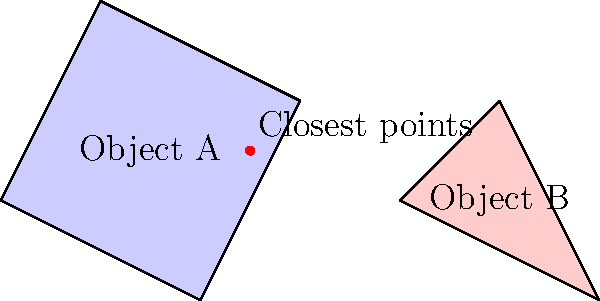In a physics-based puzzle game, you need to calculate the collision detection between two irregularly shaped objects, A and B, as shown in the diagram. If the shortest distance between any two points on these objects is less than 0.5 units, a collision occurs. Given that the closest points between the objects are (2.5, 0.5) on object A and (4, 0) on object B, determine if a collision has occurred. What is the distance between these closest points? To solve this problem, we need to calculate the distance between the two closest points and compare it to the collision threshold. Let's break it down step-by-step:

1. Identify the coordinates of the closest points:
   - Point on Object A: (2.5, 0.5)
   - Point on Object B: (4, 0)

2. Calculate the distance using the distance formula between two points:
   $d = \sqrt{(x_2 - x_1)^2 + (y_2 - y_1)^2}$

   Where:
   $(x_1, y_1)$ is (2.5, 0.5)
   $(x_2, y_2)$ is (4, 0)

3. Plug the values into the formula:
   $d = \sqrt{(4 - 2.5)^2 + (0 - 0.5)^2}$

4. Simplify:
   $d = \sqrt{1.5^2 + (-0.5)^2}$
   $d = \sqrt{2.25 + 0.25}$
   $d = \sqrt{2.5}$

5. Calculate the final value:
   $d \approx 1.58$ units

6. Compare with the collision threshold:
   The distance (1.58 units) is greater than the collision threshold (0.5 units), so no collision has occurred.

The distance between the closest points is approximately 1.58 units.
Answer: 1.58 units 